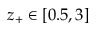Convert formula to latex. <formula><loc_0><loc_0><loc_500><loc_500>z _ { + } \in [ 0 . 5 , 3 ]</formula> 